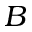Convert formula to latex. <formula><loc_0><loc_0><loc_500><loc_500>B</formula> 